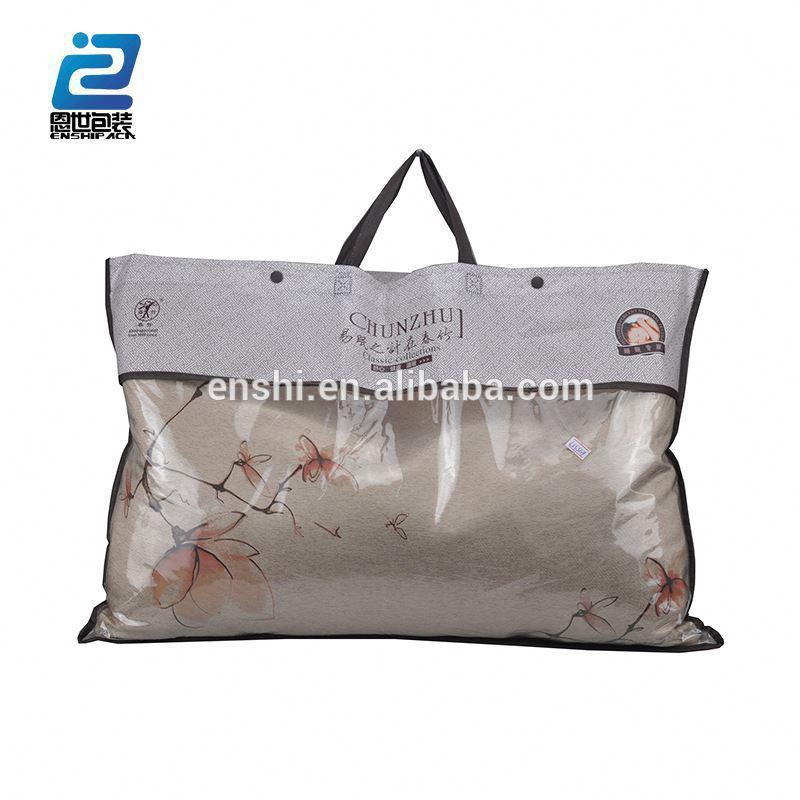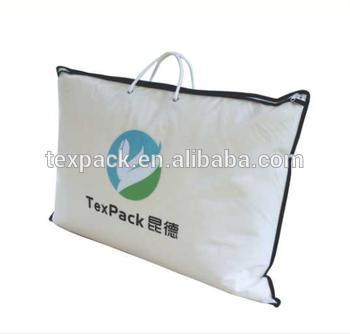The first image is the image on the left, the second image is the image on the right. Analyze the images presented: Is the assertion "Each image shows a pillow bag with at least one handle, and one image displays a bag head-on, while the other displays a bag at an angle." valid? Answer yes or no. Yes. The first image is the image on the left, the second image is the image on the right. Given the left and right images, does the statement "In at least one image there is a pillow in a plastic zip bag that has gold plastic on the top fourth." hold true? Answer yes or no. No. 